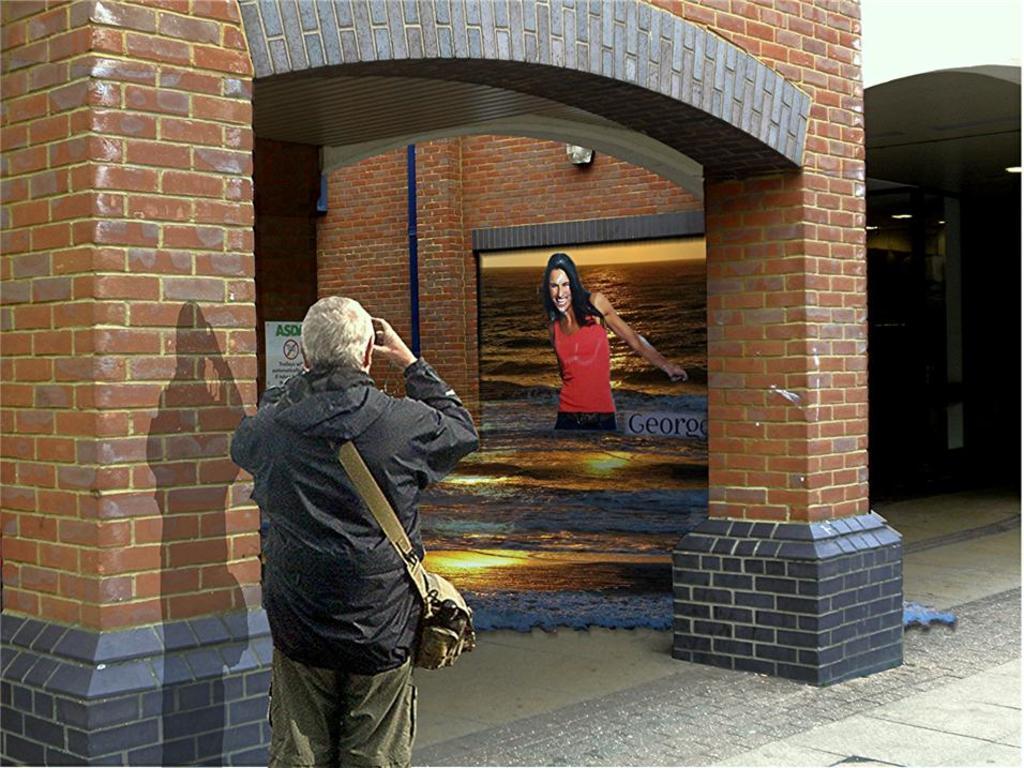Can you describe this image briefly? In this picture we can see two buildings, there is a person standing in the front, this person is carrying a bag, on the left side there is a board, we can see wall art and a pipe in the middle, we can see picture of a person and water on the wall. 